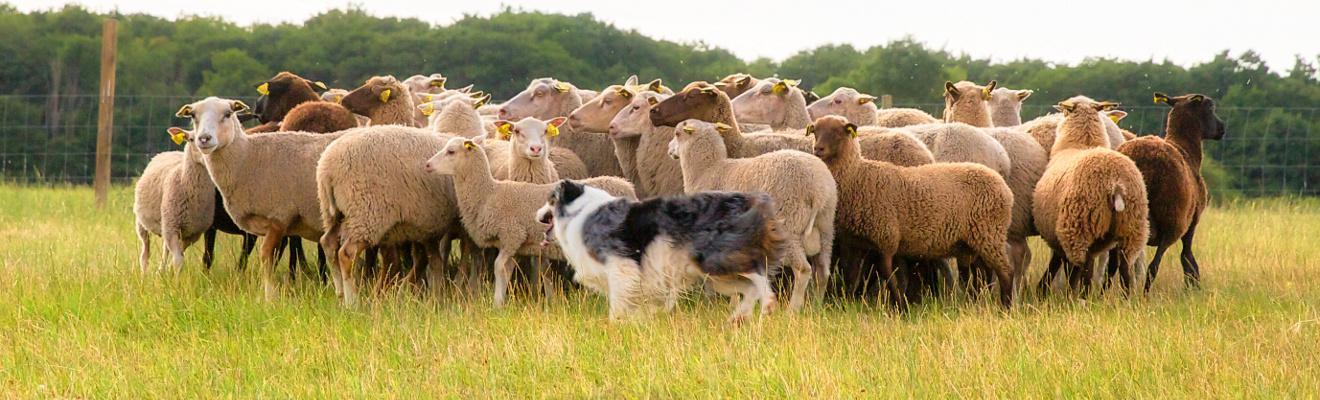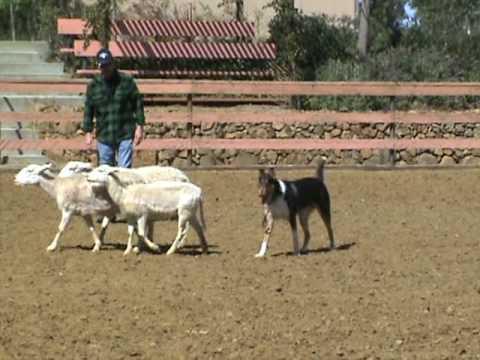The first image is the image on the left, the second image is the image on the right. Considering the images on both sides, is "An image features a person standing in front of a plank fence and behind multiple sheep, with a dog nearby." valid? Answer yes or no. Yes. The first image is the image on the left, the second image is the image on the right. For the images displayed, is the sentence "The right image contains a dog chasing sheep towards the right." factually correct? Answer yes or no. No. 